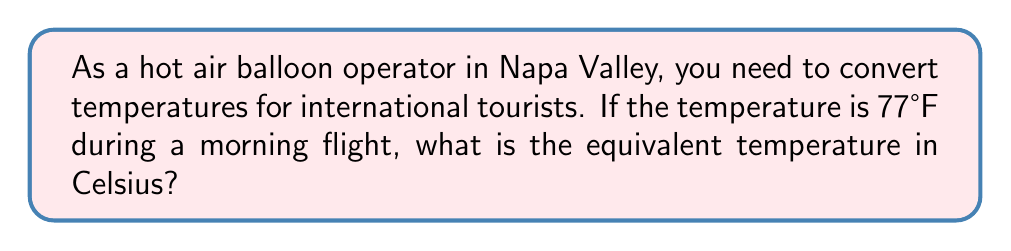Help me with this question. To convert temperatures from Fahrenheit to Celsius, we use the following formula:

$$ C = \frac{5}{9}(F - 32) $$

Where $C$ is the temperature in Celsius and $F$ is the temperature in Fahrenheit.

Let's follow the steps:

1) We have $F = 77°F$

2) Plug this into the formula:
   $$ C = \frac{5}{9}(77 - 32) $$

3) First, calculate the value inside the parentheses:
   $$ C = \frac{5}{9}(45) $$

4) Now multiply:
   $$ C = \frac{5 \times 45}{9} = \frac{225}{9} $$

5) Divide:
   $$ C = 25 $$

Therefore, 77°F is equivalent to 25°C.
Answer: 25°C 